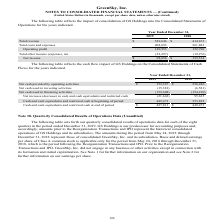From Greensky's financial document, Which years does the table show? The document shows two values: 2019 and 2018. From the document: "Year Ended December 31, 2019 2018 Year Ended December 31, 2019 2018..." Also, What was the total revenue in 2018? According to the financial document, 414,673 (in thousands). The relevant text states: "Total revenue $ 529,646 $ 414,673..." Also, What was the operating profit in 2019? According to the financial document, 120,953 (in thousands). The relevant text states: "Operating profit 120,953 152,790..." Also, How many years did Total costs and expenses exceed $200,000 thousand? Counting the relevant items in the document: 2019, 2018, I find 2 instances. The key data points involved are: 2018, 2019. Also, can you calculate: What was the change in operating profit between 2018 and 2019? Based on the calculation: 120,953-152,790, the result is -31837 (in thousands). This is based on the information: "Operating profit 120,953 152,790 Operating profit 120,953 152,790..." The key data points involved are: 120,953, 152,790. Also, can you calculate: What was the percentage change in the net income between 2018 and 2019? To answer this question, I need to perform calculations using the financial data. The calculation is: (98,656-133,514)/133,514, which equals -26.11 (percentage). This is based on the information: "Net income $ 98,656 $ 133,514 Net income $ 98,656 $ 133,514..." The key data points involved are: 133,514, 98,656. 